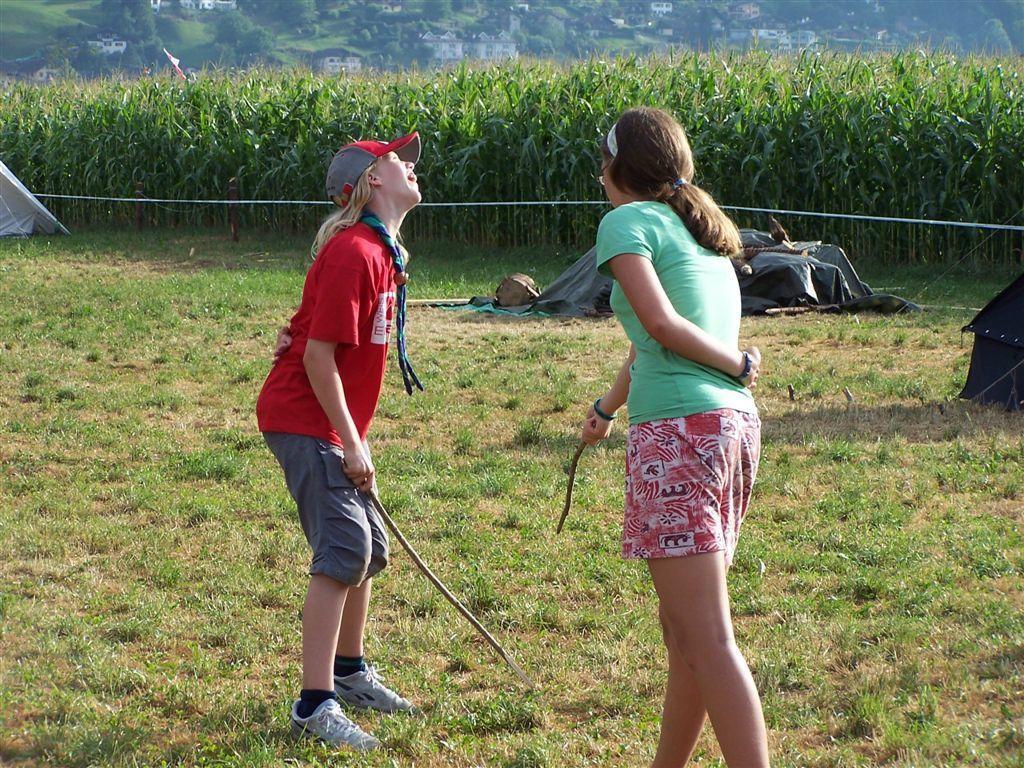Could you give a brief overview of what you see in this image? In this picture we can see two girls standing on the ground and in the background we can see trees. 